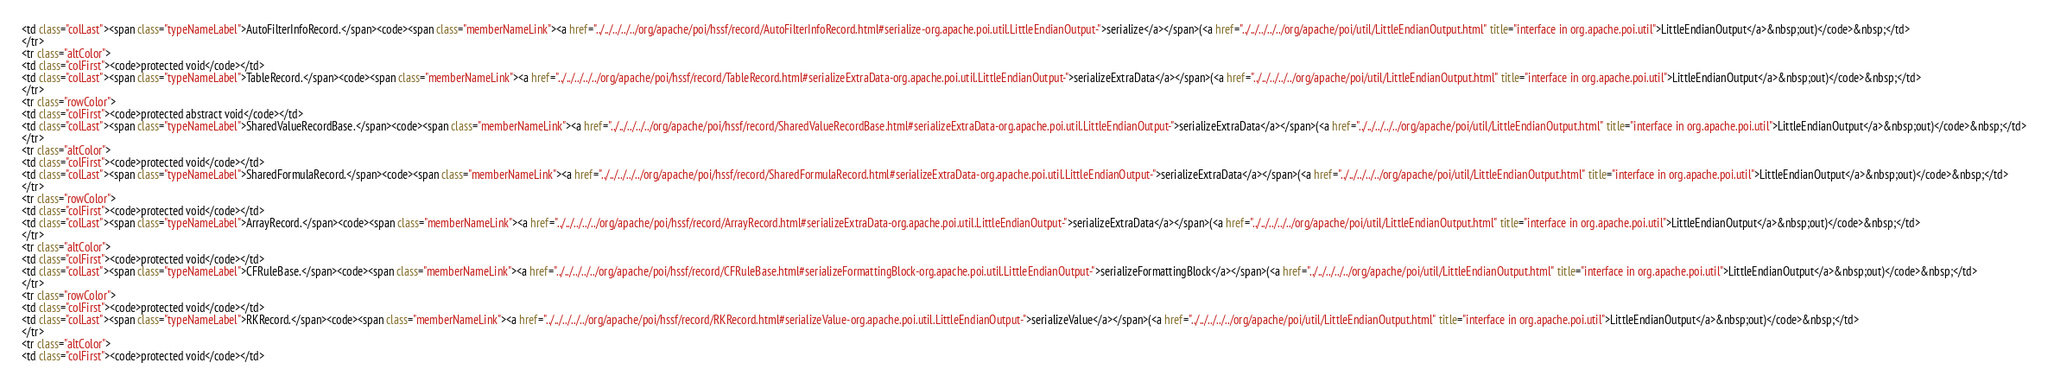Convert code to text. <code><loc_0><loc_0><loc_500><loc_500><_HTML_><td class="colLast"><span class="typeNameLabel">AutoFilterInfoRecord.</span><code><span class="memberNameLink"><a href="../../../../../org/apache/poi/hssf/record/AutoFilterInfoRecord.html#serialize-org.apache.poi.util.LittleEndianOutput-">serialize</a></span>(<a href="../../../../../org/apache/poi/util/LittleEndianOutput.html" title="interface in org.apache.poi.util">LittleEndianOutput</a>&nbsp;out)</code>&nbsp;</td>
</tr>
<tr class="altColor">
<td class="colFirst"><code>protected void</code></td>
<td class="colLast"><span class="typeNameLabel">TableRecord.</span><code><span class="memberNameLink"><a href="../../../../../org/apache/poi/hssf/record/TableRecord.html#serializeExtraData-org.apache.poi.util.LittleEndianOutput-">serializeExtraData</a></span>(<a href="../../../../../org/apache/poi/util/LittleEndianOutput.html" title="interface in org.apache.poi.util">LittleEndianOutput</a>&nbsp;out)</code>&nbsp;</td>
</tr>
<tr class="rowColor">
<td class="colFirst"><code>protected abstract void</code></td>
<td class="colLast"><span class="typeNameLabel">SharedValueRecordBase.</span><code><span class="memberNameLink"><a href="../../../../../org/apache/poi/hssf/record/SharedValueRecordBase.html#serializeExtraData-org.apache.poi.util.LittleEndianOutput-">serializeExtraData</a></span>(<a href="../../../../../org/apache/poi/util/LittleEndianOutput.html" title="interface in org.apache.poi.util">LittleEndianOutput</a>&nbsp;out)</code>&nbsp;</td>
</tr>
<tr class="altColor">
<td class="colFirst"><code>protected void</code></td>
<td class="colLast"><span class="typeNameLabel">SharedFormulaRecord.</span><code><span class="memberNameLink"><a href="../../../../../org/apache/poi/hssf/record/SharedFormulaRecord.html#serializeExtraData-org.apache.poi.util.LittleEndianOutput-">serializeExtraData</a></span>(<a href="../../../../../org/apache/poi/util/LittleEndianOutput.html" title="interface in org.apache.poi.util">LittleEndianOutput</a>&nbsp;out)</code>&nbsp;</td>
</tr>
<tr class="rowColor">
<td class="colFirst"><code>protected void</code></td>
<td class="colLast"><span class="typeNameLabel">ArrayRecord.</span><code><span class="memberNameLink"><a href="../../../../../org/apache/poi/hssf/record/ArrayRecord.html#serializeExtraData-org.apache.poi.util.LittleEndianOutput-">serializeExtraData</a></span>(<a href="../../../../../org/apache/poi/util/LittleEndianOutput.html" title="interface in org.apache.poi.util">LittleEndianOutput</a>&nbsp;out)</code>&nbsp;</td>
</tr>
<tr class="altColor">
<td class="colFirst"><code>protected void</code></td>
<td class="colLast"><span class="typeNameLabel">CFRuleBase.</span><code><span class="memberNameLink"><a href="../../../../../org/apache/poi/hssf/record/CFRuleBase.html#serializeFormattingBlock-org.apache.poi.util.LittleEndianOutput-">serializeFormattingBlock</a></span>(<a href="../../../../../org/apache/poi/util/LittleEndianOutput.html" title="interface in org.apache.poi.util">LittleEndianOutput</a>&nbsp;out)</code>&nbsp;</td>
</tr>
<tr class="rowColor">
<td class="colFirst"><code>protected void</code></td>
<td class="colLast"><span class="typeNameLabel">RKRecord.</span><code><span class="memberNameLink"><a href="../../../../../org/apache/poi/hssf/record/RKRecord.html#serializeValue-org.apache.poi.util.LittleEndianOutput-">serializeValue</a></span>(<a href="../../../../../org/apache/poi/util/LittleEndianOutput.html" title="interface in org.apache.poi.util">LittleEndianOutput</a>&nbsp;out)</code>&nbsp;</td>
</tr>
<tr class="altColor">
<td class="colFirst"><code>protected void</code></td></code> 